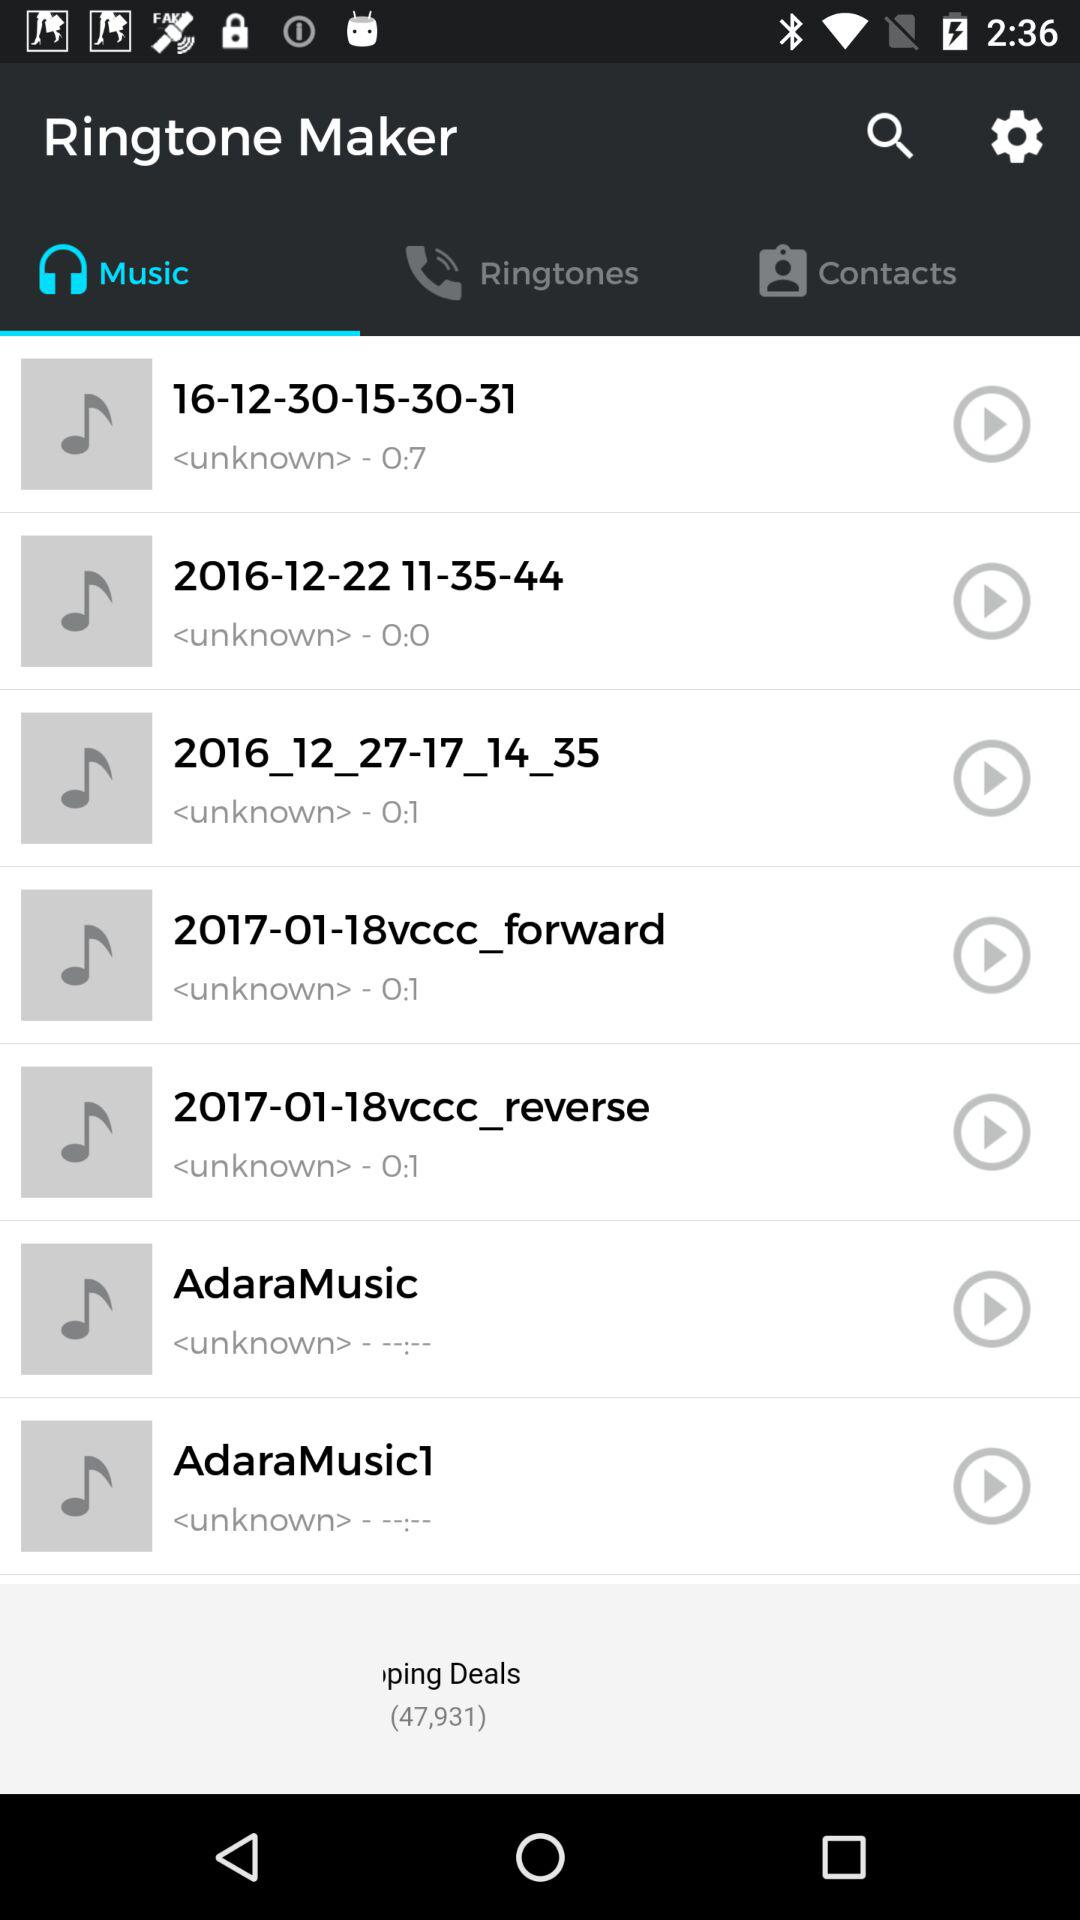What is the application name? The application name is "Ringtone Maker". 